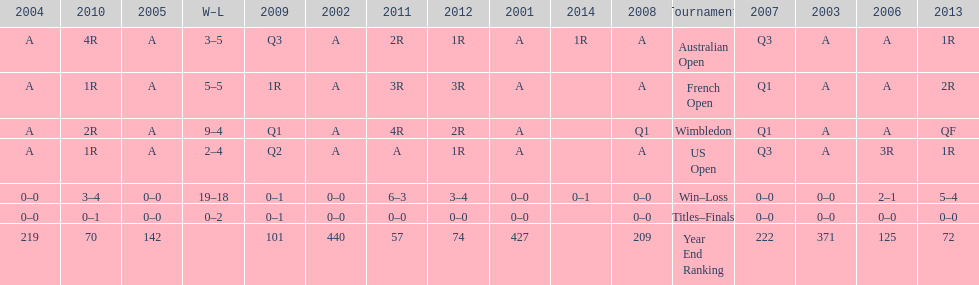In which years were there only 1 loss? 2006, 2009, 2014. 